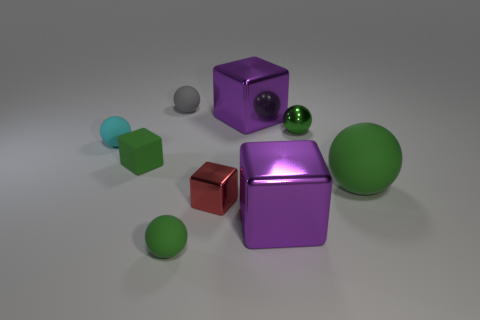How many other things are the same color as the metallic sphere?
Your answer should be very brief. 3. There is a block that is both behind the large rubber sphere and right of the green cube; what is its material?
Make the answer very short. Metal. Do the large sphere and the red cube to the left of the small green shiny thing have the same material?
Make the answer very short. No. Are there more spheres that are behind the large green rubber ball than metal spheres in front of the red metal cube?
Your answer should be very brief. Yes. There is a red object; what shape is it?
Provide a short and direct response. Cube. Is the material of the small green sphere that is in front of the red cube the same as the big cube behind the red metal object?
Keep it short and to the point. No. There is a purple metal thing behind the small green matte block; what shape is it?
Ensure brevity in your answer.  Cube. Is the color of the rubber block the same as the big rubber object?
Provide a succinct answer. Yes. Are there any big metal objects that are behind the big purple metal object in front of the small red metallic thing?
Keep it short and to the point. Yes. How many metallic balls are the same color as the large matte sphere?
Offer a very short reply. 1. 